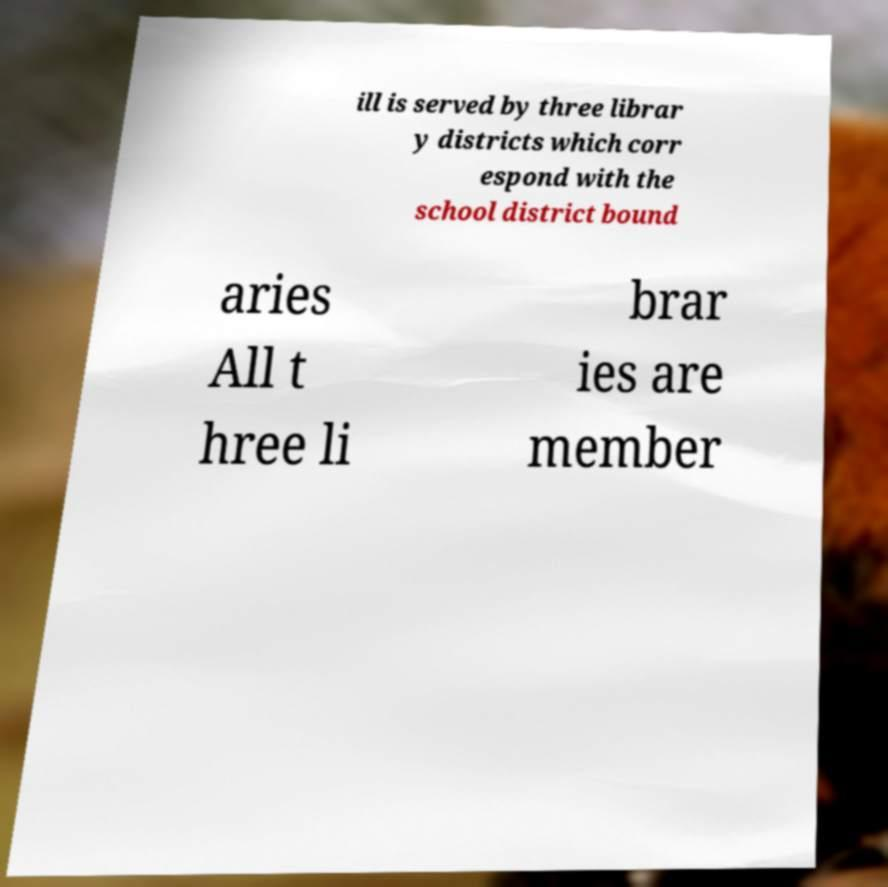What messages or text are displayed in this image? I need them in a readable, typed format. ill is served by three librar y districts which corr espond with the school district bound aries All t hree li brar ies are member 